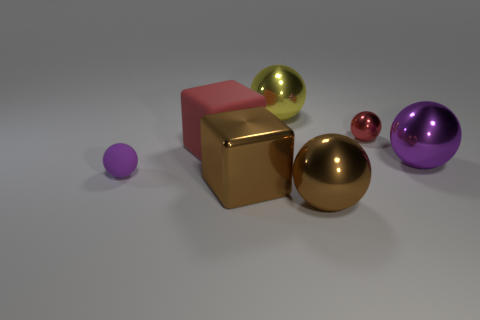Subtract all big balls. How many balls are left? 2 Add 2 tiny cyan metallic balls. How many objects exist? 9 Subtract all red spheres. How many spheres are left? 4 Subtract 1 cubes. How many cubes are left? 1 Subtract all cubes. How many objects are left? 5 Add 2 tiny red rubber objects. How many tiny red rubber objects exist? 2 Subtract 0 cyan balls. How many objects are left? 7 Subtract all purple spheres. Subtract all blue blocks. How many spheres are left? 3 Subtract all purple balls. How many purple blocks are left? 0 Subtract all cubes. Subtract all purple shiny spheres. How many objects are left? 4 